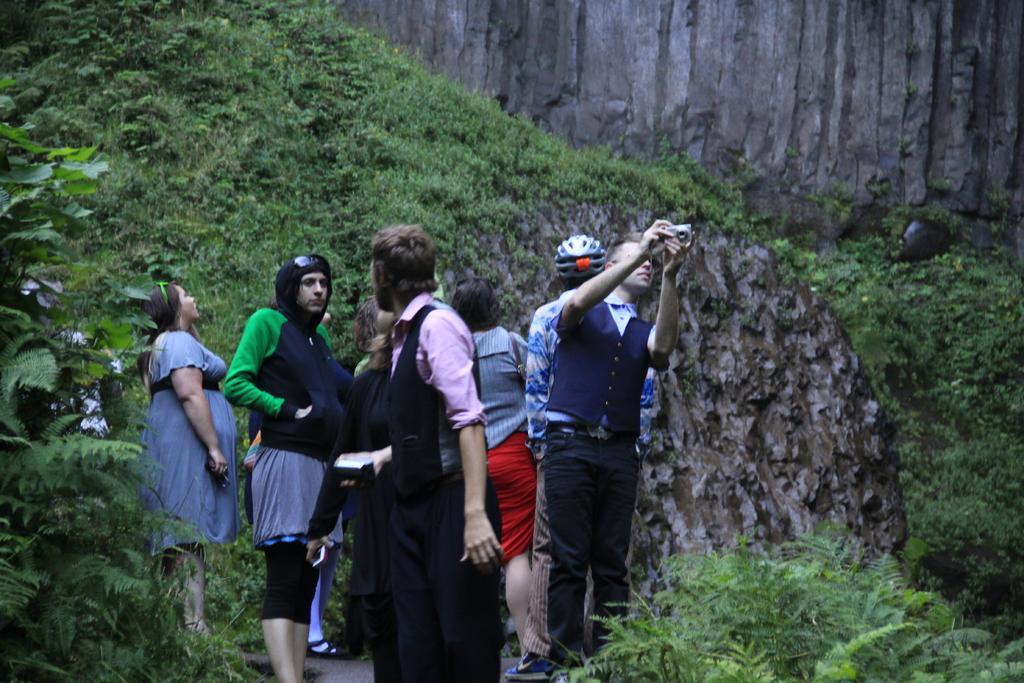Describe this image in one or two sentences. There are group of people standing. I think this is a hill. I can see the trees and plants, which are green in color. 